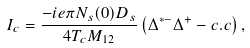<formula> <loc_0><loc_0><loc_500><loc_500>I _ { c } = \frac { - i e \pi N _ { s } ( 0 ) D _ { s } } { 4 T _ { c } M _ { 1 2 } } \left ( \Delta ^ { \ast - } \Delta ^ { + } - c . c \right ) ,</formula> 